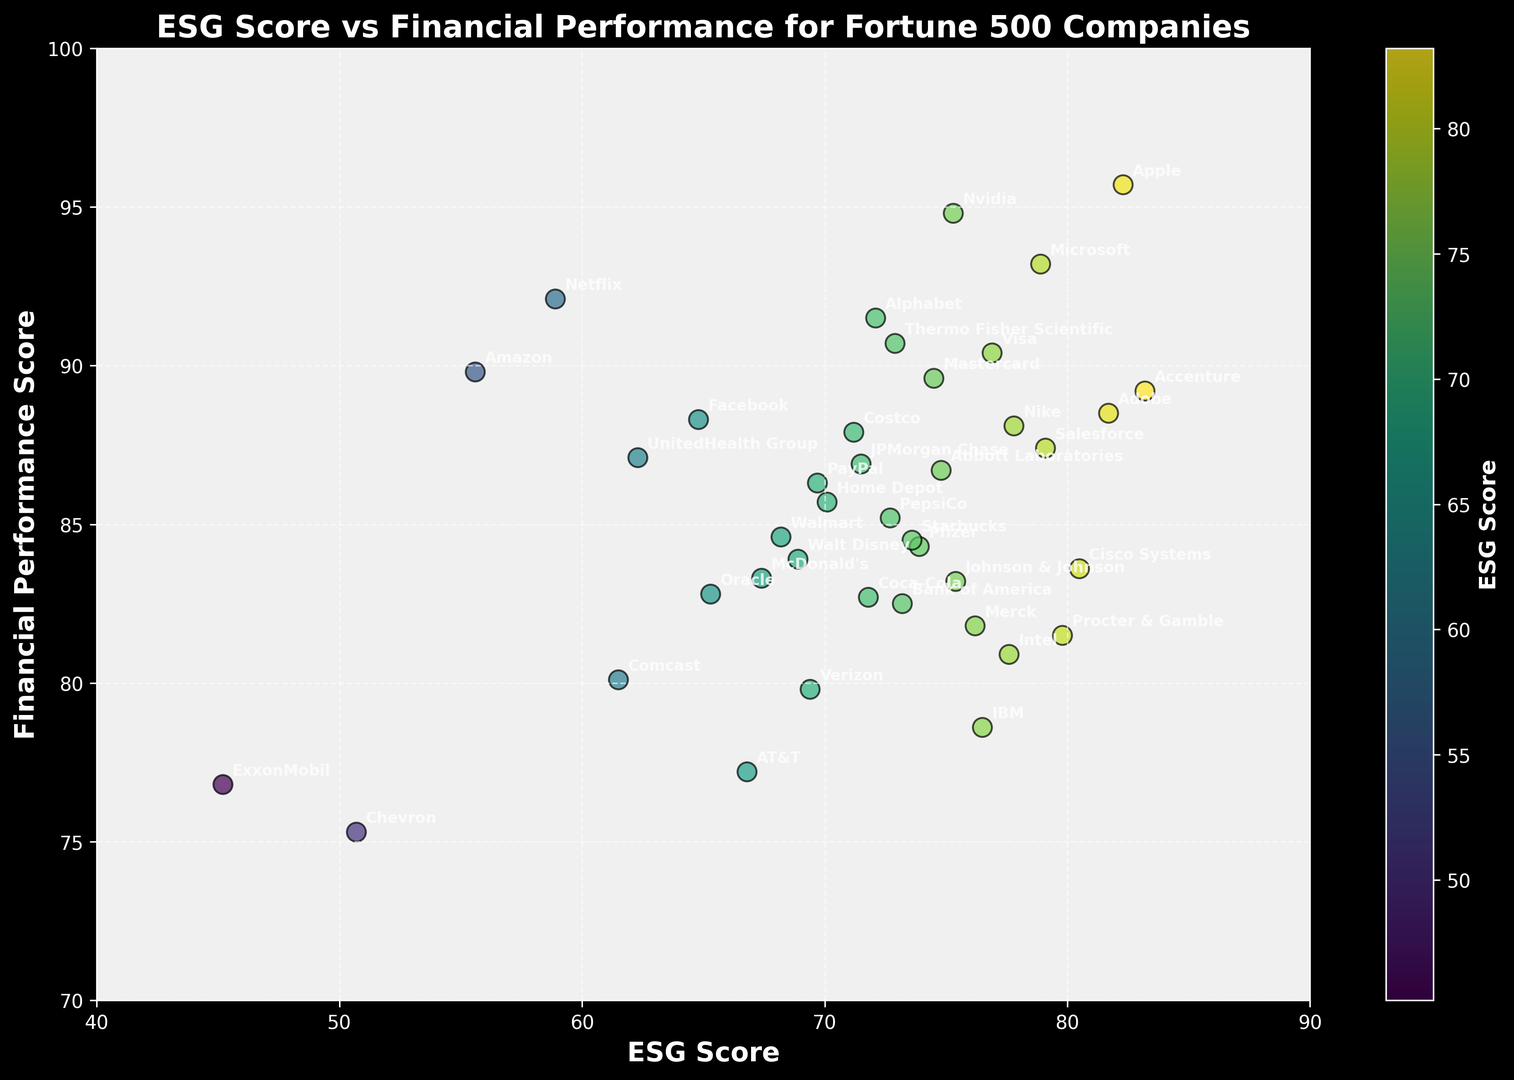What's the highest financial performance score? From the scatter plot, identify the data point with the maximum y-axis value. It's clear that the highest financial performance score corresponds to Apple with a score of 95.7.
Answer: 95.7 How does the ESG score of Amazon compare to that of ExxonMobil? Locate the data points for Amazon and ExxonMobil on the scatter plot. Amazon has an ESG score of 55.6, while ExxonMobil has an ESG score of 45.2. Therefore, Amazon's ESG score is higher than ExxonMobil's.
Answer: Amazon's ESG score is higher Which company has the highest ESG score and what is its financial performance score? Find the data point with the maximum x-axis value and identify the corresponding company. Accenture has the highest ESG score of 83.2. Its financial performance score is 89.2.
Answer: Accenture, 89.2 What's the difference in financial performance scores between Apple and Facebook? Identify the y-axis positions for Apple (95.7) and Facebook (88.3) from the scatter plot. Subtract Facebook's score from Apple's score: 95.7 - 88.3 = 7.4.
Answer: 7.4 Is there a company with an ESG score over 70 and a financial performance score below 80? On the scatter plot, look for a data point with an x-value over 70 and a y-value below 80. IBM fits this criterion, having an ESG score of 76.5 and a financial performance score of 78.6.
Answer: Yes, IBM Which two companies have the closest financial performance scores, and what are those scores? From the scatter plot, compare the vertical distances between the data points. Pfizer (84.3) and Starbucks (84.5) are the closest, with a difference of only 0.2.
Answer: Pfizer (84.3) and Starbucks (84.5) How many companies have an ESG score below 60? From the scatter plot, count the number of data points with an x-value less than 60. These companies are Amazon, ExxonMobil, Chevron, and Netflix, totaling 4 companies.
Answer: 4 For companies with a financial performance score above 90, what is the average ESG score? Identify the companies with y-values above 90 (Apple, Microsoft, Netflix, Nvidia, Alphabet, Visa, Thermo Fisher Scientific, and Accenture). Sum their ESG scores (82.3 + 78.9 + 58.9 + 75.3 + 72.1 + 76.9 + 72.9 + 83.2 = 600.5) and divide by the number of companies (8): 600.5 / 8 = 75.1.
Answer: 75.1 What is the correlation between ESG score and financial performance score? Visually inspect the scatter plot trend. A positive correlation is indicated as higher ESG scores generally map to higher financial performance scores. This suggests that companies with better ESG scores tend to also have better financial performance.
Answer: Positive correlation 